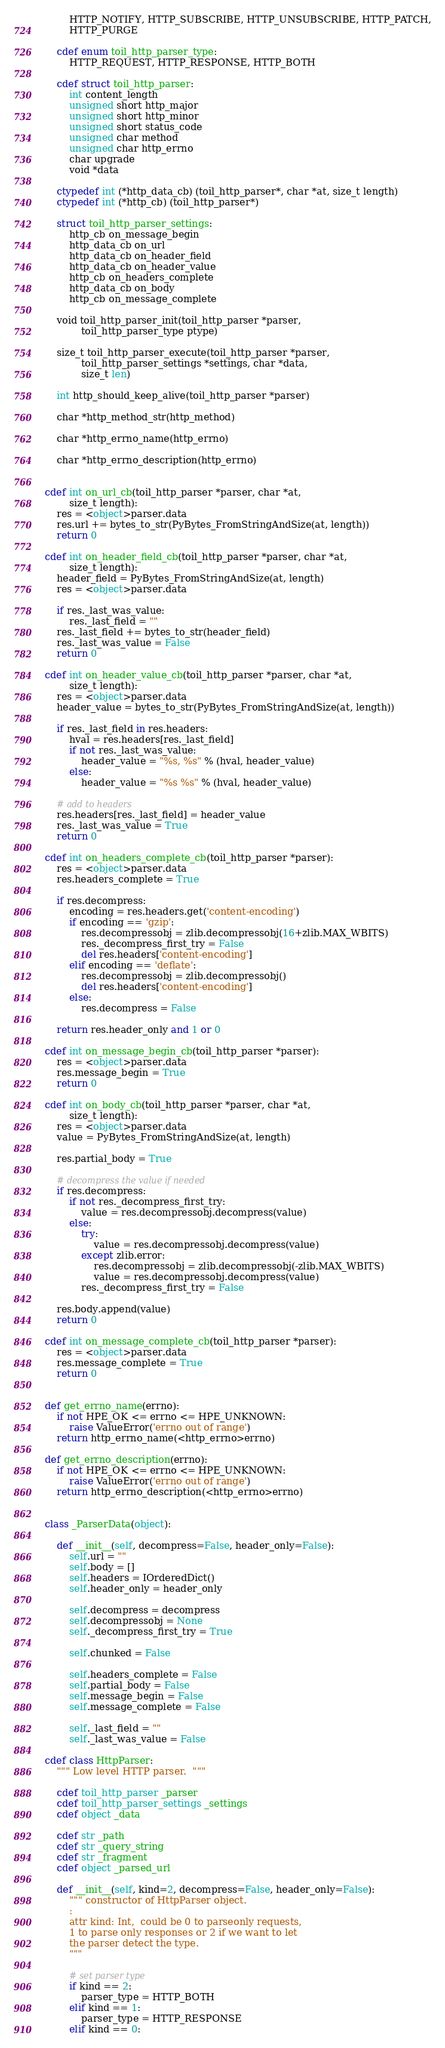Convert code to text. <code><loc_0><loc_0><loc_500><loc_500><_Cython_>        HTTP_NOTIFY, HTTP_SUBSCRIBE, HTTP_UNSUBSCRIBE, HTTP_PATCH,
        HTTP_PURGE

    cdef enum toil_http_parser_type:
        HTTP_REQUEST, HTTP_RESPONSE, HTTP_BOTH

    cdef struct toil_http_parser:
        int content_length
        unsigned short http_major
        unsigned short http_minor
        unsigned short status_code
        unsigned char method
        unsigned char http_errno
        char upgrade
        void *data

    ctypedef int (*http_data_cb) (toil_http_parser*, char *at, size_t length)
    ctypedef int (*http_cb) (toil_http_parser*)

    struct toil_http_parser_settings:
        http_cb on_message_begin
        http_data_cb on_url
        http_data_cb on_header_field
        http_data_cb on_header_value
        http_cb on_headers_complete
        http_data_cb on_body
        http_cb on_message_complete

    void toil_http_parser_init(toil_http_parser *parser,
            toil_http_parser_type ptype)

    size_t toil_http_parser_execute(toil_http_parser *parser,
            toil_http_parser_settings *settings, char *data,
            size_t len)

    int http_should_keep_alive(toil_http_parser *parser)

    char *http_method_str(http_method)

    char *http_errno_name(http_errno)

    char *http_errno_description(http_errno)


cdef int on_url_cb(toil_http_parser *parser, char *at,
        size_t length):
    res = <object>parser.data
    res.url += bytes_to_str(PyBytes_FromStringAndSize(at, length))
    return 0

cdef int on_header_field_cb(toil_http_parser *parser, char *at,
        size_t length):
    header_field = PyBytes_FromStringAndSize(at, length)
    res = <object>parser.data

    if res._last_was_value:
        res._last_field = ""
    res._last_field += bytes_to_str(header_field)
    res._last_was_value = False
    return 0

cdef int on_header_value_cb(toil_http_parser *parser, char *at,
        size_t length):
    res = <object>parser.data
    header_value = bytes_to_str(PyBytes_FromStringAndSize(at, length))

    if res._last_field in res.headers:
        hval = res.headers[res._last_field]
        if not res._last_was_value:
            header_value = "%s, %s" % (hval, header_value)
        else:
            header_value = "%s %s" % (hval, header_value)

    # add to headers
    res.headers[res._last_field] = header_value
    res._last_was_value = True
    return 0

cdef int on_headers_complete_cb(toil_http_parser *parser):
    res = <object>parser.data
    res.headers_complete = True

    if res.decompress:
        encoding = res.headers.get('content-encoding')
        if encoding == 'gzip':
            res.decompressobj = zlib.decompressobj(16+zlib.MAX_WBITS)
            res._decompress_first_try = False
            del res.headers['content-encoding']
        elif encoding == 'deflate':
            res.decompressobj = zlib.decompressobj()
            del res.headers['content-encoding']
        else:
            res.decompress = False

    return res.header_only and 1 or 0

cdef int on_message_begin_cb(toil_http_parser *parser):
    res = <object>parser.data
    res.message_begin = True
    return 0

cdef int on_body_cb(toil_http_parser *parser, char *at,
        size_t length):
    res = <object>parser.data
    value = PyBytes_FromStringAndSize(at, length)

    res.partial_body = True

    # decompress the value if needed
    if res.decompress:
        if not res._decompress_first_try:
            value = res.decompressobj.decompress(value)
        else:
            try:
                value = res.decompressobj.decompress(value)
            except zlib.error:
                res.decompressobj = zlib.decompressobj(-zlib.MAX_WBITS)
                value = res.decompressobj.decompress(value)
            res._decompress_first_try = False

    res.body.append(value)
    return 0

cdef int on_message_complete_cb(toil_http_parser *parser):
    res = <object>parser.data
    res.message_complete = True
    return 0


def get_errno_name(errno):
    if not HPE_OK <= errno <= HPE_UNKNOWN:
        raise ValueError('errno out of range')
    return http_errno_name(<http_errno>errno)

def get_errno_description(errno):
    if not HPE_OK <= errno <= HPE_UNKNOWN:
        raise ValueError('errno out of range')
    return http_errno_description(<http_errno>errno)


class _ParserData(object):

    def __init__(self, decompress=False, header_only=False):
        self.url = ""
        self.body = []
        self.headers = IOrderedDict()
        self.header_only = header_only

        self.decompress = decompress
        self.decompressobj = None
        self._decompress_first_try = True

        self.chunked = False

        self.headers_complete = False
        self.partial_body = False
        self.message_begin = False
        self.message_complete = False

        self._last_field = ""
        self._last_was_value = False

cdef class HttpParser:
    """ Low level HTTP parser.  """

    cdef toil_http_parser _parser
    cdef toil_http_parser_settings _settings
    cdef object _data

    cdef str _path
    cdef str _query_string
    cdef str _fragment
    cdef object _parsed_url

    def __init__(self, kind=2, decompress=False, header_only=False):
        """ constructor of HttpParser object.
        :
        attr kind: Int,  could be 0 to parseonly requests,
        1 to parse only responses or 2 if we want to let
        the parser detect the type.
        """

        # set parser type
        if kind == 2:
            parser_type = HTTP_BOTH
        elif kind == 1:
            parser_type = HTTP_RESPONSE
        elif kind == 0:</code> 